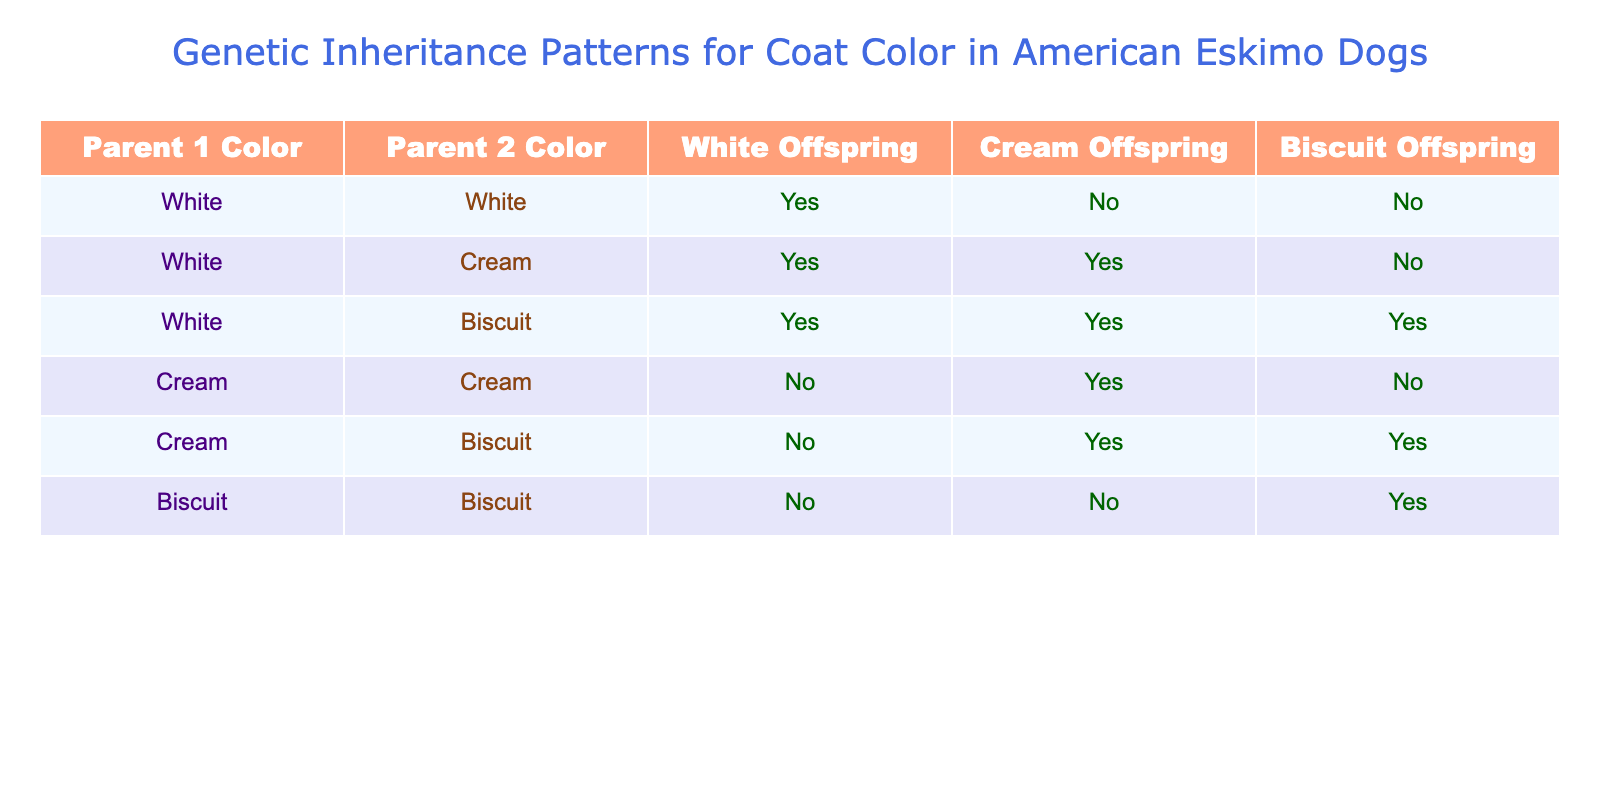What offspring color can be expected from two white parent dogs? According to the table, when both parents are white, they only produce white offspring. This is directly indicated in the row where both Parent 1 and Parent 2 are listed as White, showing a Yes for White Offspring.
Answer: Yes Can a cream dog and a biscuit dog produce white offspring? The table shows that when one parent is Cream and the other is Biscuit, white offspring will not be produced, as indicated by the row with these colors showing No for White Offspring.
Answer: No How many different offspring colors can result from a white and biscuit pairing? From the table, the combination of white and biscuit parents results in white, cream, and biscuit offspring. The row indicates Yes for all three outcomes. Thus, there are 3 different offspring colors.
Answer: 3 Is it true that cream and cream parents can only produce cream offspring? Looking at the row for two cream parents, it shows that they produce no white offspring, but one cream offspring (Yes under Cream Offspring) and no biscuit offspring. Therefore, it is not true that they can only produce cream.
Answer: No If both parents are biscuit, what types of offspring can be expected? The table specifies that two biscuit parents only produce biscuit offspring, as indicated by the row showing No for white and cream, and Yes for biscuit. This means they are restricted to only one type of offspring color.
Answer: Biscuit only How many combinations can produce a cream offspring, and what are the parent pairings? To answer this question, we look at the table for all instances of "Yes" under Cream Offspring. Both the white and cream pairing, as well as the cream and biscuit pairing, result in cream offspring. Hence, there are two combinations: White with Cream, and Cream with Biscuit.
Answer: 2 combinations: White & Cream, Cream & Biscuit Can a white dog and a cream dog produce any biscuit offspring? According to the table, a white and cream pairing can only produce either white or cream offspring, but definitely no biscuit offspring, which is marked as No under Biscuit Offspring for that pair.
Answer: No What is the relationship between the coat colors of parents and the variety of offspring produced? The offspring variety depends on the parental combination; for instance, two white dogs only produce white, whereas a white and biscuit pairing can lead to all three colors (white, cream, biscuit), reflecting a more varied inheritance when different colors are mixed.
Answer: Mixed colors yield more variety 